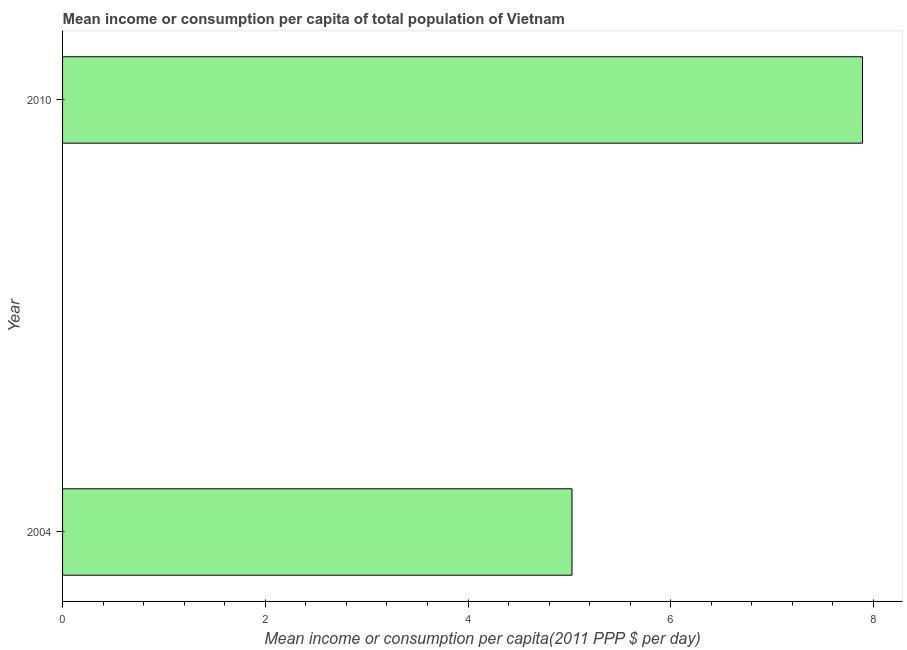Does the graph contain any zero values?
Make the answer very short. No. Does the graph contain grids?
Ensure brevity in your answer.  No. What is the title of the graph?
Give a very brief answer. Mean income or consumption per capita of total population of Vietnam. What is the label or title of the X-axis?
Offer a terse response. Mean income or consumption per capita(2011 PPP $ per day). What is the mean income or consumption in 2010?
Offer a very short reply. 7.89. Across all years, what is the maximum mean income or consumption?
Offer a very short reply. 7.89. Across all years, what is the minimum mean income or consumption?
Ensure brevity in your answer.  5.03. In which year was the mean income or consumption maximum?
Offer a very short reply. 2010. In which year was the mean income or consumption minimum?
Offer a very short reply. 2004. What is the sum of the mean income or consumption?
Your response must be concise. 12.92. What is the difference between the mean income or consumption in 2004 and 2010?
Give a very brief answer. -2.87. What is the average mean income or consumption per year?
Offer a very short reply. 6.46. What is the median mean income or consumption?
Provide a succinct answer. 6.46. In how many years, is the mean income or consumption greater than 2.4 $?
Make the answer very short. 2. What is the ratio of the mean income or consumption in 2004 to that in 2010?
Offer a very short reply. 0.64. In how many years, is the mean income or consumption greater than the average mean income or consumption taken over all years?
Your response must be concise. 1. How many bars are there?
Provide a short and direct response. 2. Are all the bars in the graph horizontal?
Make the answer very short. Yes. What is the Mean income or consumption per capita(2011 PPP $ per day) in 2004?
Ensure brevity in your answer.  5.03. What is the Mean income or consumption per capita(2011 PPP $ per day) of 2010?
Offer a very short reply. 7.89. What is the difference between the Mean income or consumption per capita(2011 PPP $ per day) in 2004 and 2010?
Keep it short and to the point. -2.87. What is the ratio of the Mean income or consumption per capita(2011 PPP $ per day) in 2004 to that in 2010?
Your answer should be very brief. 0.64. 